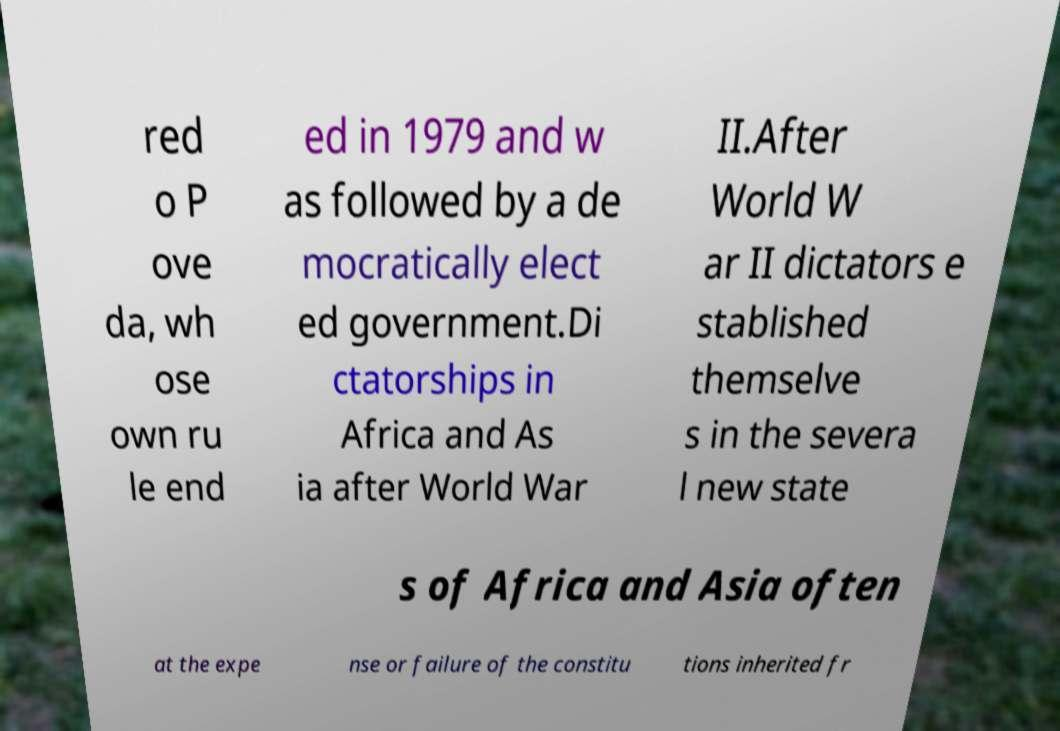Please read and relay the text visible in this image. What does it say? red o P ove da, wh ose own ru le end ed in 1979 and w as followed by a de mocratically elect ed government.Di ctatorships in Africa and As ia after World War II.After World W ar II dictators e stablished themselve s in the severa l new state s of Africa and Asia often at the expe nse or failure of the constitu tions inherited fr 